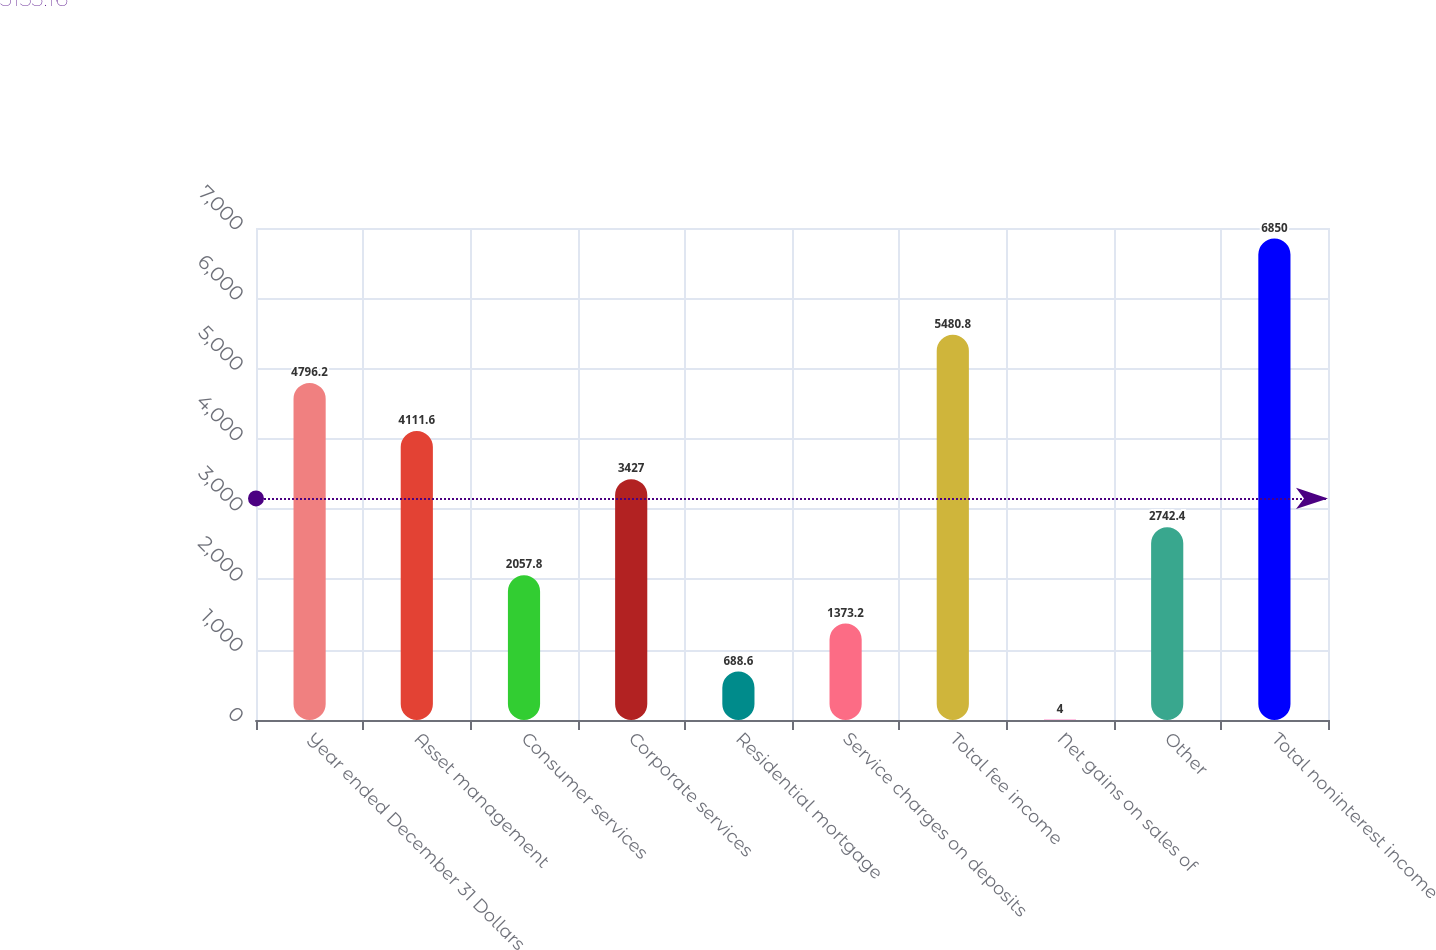Convert chart. <chart><loc_0><loc_0><loc_500><loc_500><bar_chart><fcel>Year ended December 31 Dollars<fcel>Asset management<fcel>Consumer services<fcel>Corporate services<fcel>Residential mortgage<fcel>Service charges on deposits<fcel>Total fee income<fcel>Net gains on sales of<fcel>Other<fcel>Total noninterest income<nl><fcel>4796.2<fcel>4111.6<fcel>2057.8<fcel>3427<fcel>688.6<fcel>1373.2<fcel>5480.8<fcel>4<fcel>2742.4<fcel>6850<nl></chart> 